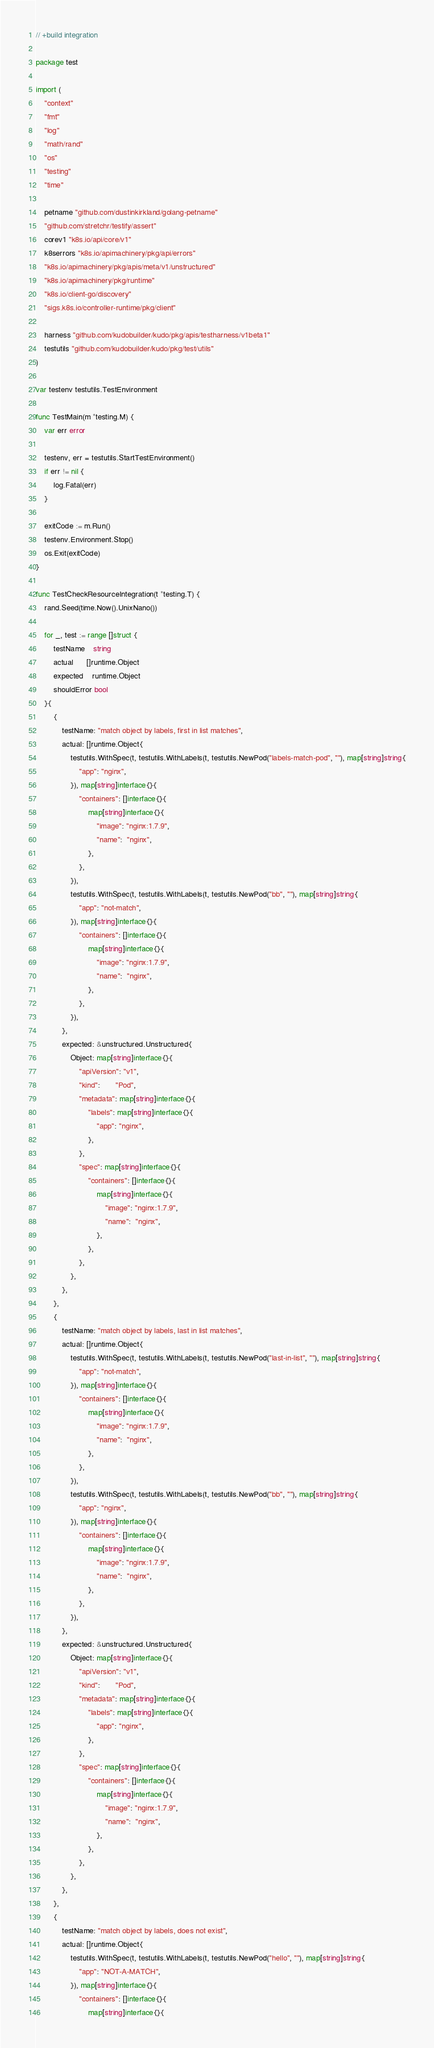<code> <loc_0><loc_0><loc_500><loc_500><_Go_>// +build integration

package test

import (
	"context"
	"fmt"
	"log"
	"math/rand"
	"os"
	"testing"
	"time"

	petname "github.com/dustinkirkland/golang-petname"
	"github.com/stretchr/testify/assert"
	corev1 "k8s.io/api/core/v1"
	k8serrors "k8s.io/apimachinery/pkg/api/errors"
	"k8s.io/apimachinery/pkg/apis/meta/v1/unstructured"
	"k8s.io/apimachinery/pkg/runtime"
	"k8s.io/client-go/discovery"
	"sigs.k8s.io/controller-runtime/pkg/client"

	harness "github.com/kudobuilder/kudo/pkg/apis/testharness/v1beta1"
	testutils "github.com/kudobuilder/kudo/pkg/test/utils"
)

var testenv testutils.TestEnvironment

func TestMain(m *testing.M) {
	var err error

	testenv, err = testutils.StartTestEnvironment()
	if err != nil {
		log.Fatal(err)
	}

	exitCode := m.Run()
	testenv.Environment.Stop()
	os.Exit(exitCode)
}

func TestCheckResourceIntegration(t *testing.T) {
	rand.Seed(time.Now().UnixNano())

	for _, test := range []struct {
		testName    string
		actual      []runtime.Object
		expected    runtime.Object
		shouldError bool
	}{
		{
			testName: "match object by labels, first in list matches",
			actual: []runtime.Object{
				testutils.WithSpec(t, testutils.WithLabels(t, testutils.NewPod("labels-match-pod", ""), map[string]string{
					"app": "nginx",
				}), map[string]interface{}{
					"containers": []interface{}{
						map[string]interface{}{
							"image": "nginx:1.7.9",
							"name":  "nginx",
						},
					},
				}),
				testutils.WithSpec(t, testutils.WithLabels(t, testutils.NewPod("bb", ""), map[string]string{
					"app": "not-match",
				}), map[string]interface{}{
					"containers": []interface{}{
						map[string]interface{}{
							"image": "nginx:1.7.9",
							"name":  "nginx",
						},
					},
				}),
			},
			expected: &unstructured.Unstructured{
				Object: map[string]interface{}{
					"apiVersion": "v1",
					"kind":       "Pod",
					"metadata": map[string]interface{}{
						"labels": map[string]interface{}{
							"app": "nginx",
						},
					},
					"spec": map[string]interface{}{
						"containers": []interface{}{
							map[string]interface{}{
								"image": "nginx:1.7.9",
								"name":  "nginx",
							},
						},
					},
				},
			},
		},
		{
			testName: "match object by labels, last in list matches",
			actual: []runtime.Object{
				testutils.WithSpec(t, testutils.WithLabels(t, testutils.NewPod("last-in-list", ""), map[string]string{
					"app": "not-match",
				}), map[string]interface{}{
					"containers": []interface{}{
						map[string]interface{}{
							"image": "nginx:1.7.9",
							"name":  "nginx",
						},
					},
				}),
				testutils.WithSpec(t, testutils.WithLabels(t, testutils.NewPod("bb", ""), map[string]string{
					"app": "nginx",
				}), map[string]interface{}{
					"containers": []interface{}{
						map[string]interface{}{
							"image": "nginx:1.7.9",
							"name":  "nginx",
						},
					},
				}),
			},
			expected: &unstructured.Unstructured{
				Object: map[string]interface{}{
					"apiVersion": "v1",
					"kind":       "Pod",
					"metadata": map[string]interface{}{
						"labels": map[string]interface{}{
							"app": "nginx",
						},
					},
					"spec": map[string]interface{}{
						"containers": []interface{}{
							map[string]interface{}{
								"image": "nginx:1.7.9",
								"name":  "nginx",
							},
						},
					},
				},
			},
		},
		{
			testName: "match object by labels, does not exist",
			actual: []runtime.Object{
				testutils.WithSpec(t, testutils.WithLabels(t, testutils.NewPod("hello", ""), map[string]string{
					"app": "NOT-A-MATCH",
				}), map[string]interface{}{
					"containers": []interface{}{
						map[string]interface{}{</code> 